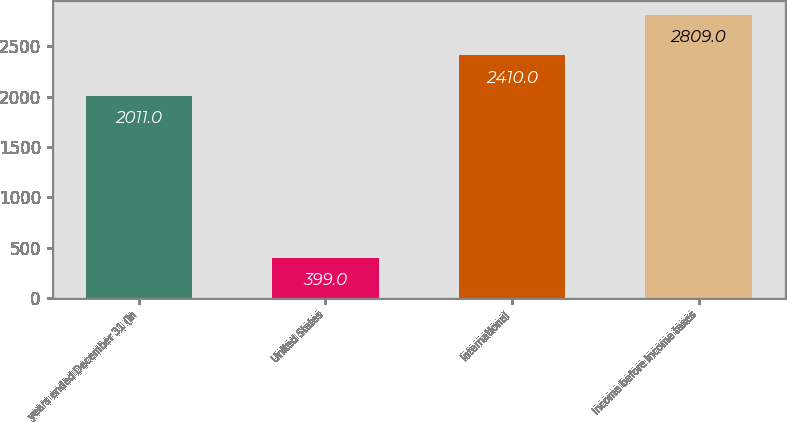Convert chart. <chart><loc_0><loc_0><loc_500><loc_500><bar_chart><fcel>years ended December 31 (in<fcel>United States<fcel>International<fcel>Income before income taxes<nl><fcel>2011<fcel>399<fcel>2410<fcel>2809<nl></chart> 